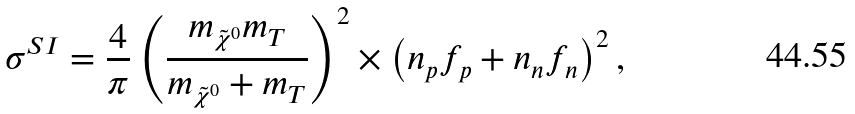<formula> <loc_0><loc_0><loc_500><loc_500>\sigma ^ { S I } = \frac { 4 } { \pi } \left ( \frac { m _ { \tilde { \chi } ^ { 0 } } m _ { T } } { m _ { \tilde { \chi } ^ { 0 } } + m _ { T } } \right ) ^ { 2 } \times \left ( n _ { p } f _ { p } + n _ { n } f _ { n } \right ) ^ { 2 } ,</formula> 